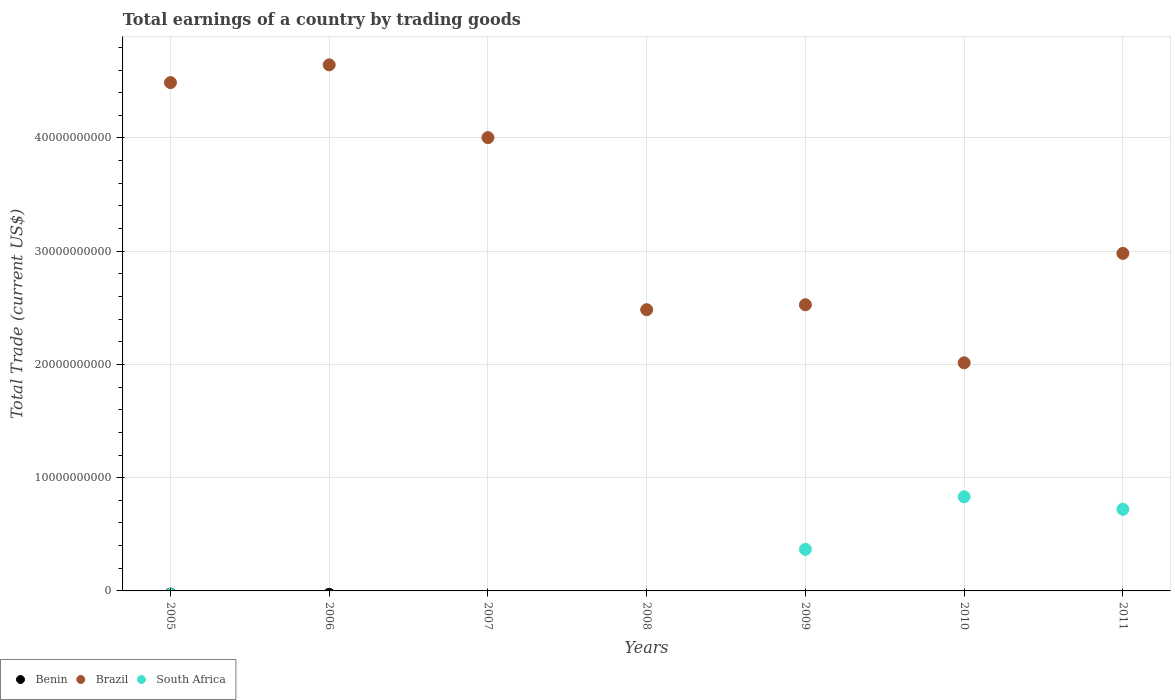Is the number of dotlines equal to the number of legend labels?
Provide a succinct answer. No. What is the total earnings in Benin in 2005?
Offer a very short reply. 0. Across all years, what is the maximum total earnings in Brazil?
Your response must be concise. 4.65e+1. Across all years, what is the minimum total earnings in South Africa?
Provide a succinct answer. 0. What is the total total earnings in Brazil in the graph?
Offer a very short reply. 2.31e+11. What is the difference between the total earnings in Brazil in 2007 and that in 2009?
Provide a short and direct response. 1.48e+1. What is the difference between the total earnings in South Africa in 2010 and the total earnings in Benin in 2008?
Your response must be concise. 8.31e+09. In the year 2009, what is the difference between the total earnings in South Africa and total earnings in Brazil?
Ensure brevity in your answer.  -2.16e+1. In how many years, is the total earnings in Brazil greater than 46000000000 US$?
Keep it short and to the point. 1. What is the ratio of the total earnings in Brazil in 2008 to that in 2011?
Your answer should be very brief. 0.83. Is the difference between the total earnings in South Africa in 2009 and 2011 greater than the difference between the total earnings in Brazil in 2009 and 2011?
Ensure brevity in your answer.  Yes. What is the difference between the highest and the second highest total earnings in Brazil?
Your answer should be very brief. 1.57e+09. What is the difference between the highest and the lowest total earnings in South Africa?
Provide a short and direct response. 8.31e+09. In how many years, is the total earnings in Benin greater than the average total earnings in Benin taken over all years?
Your answer should be compact. 0. Is the sum of the total earnings in Brazil in 2008 and 2010 greater than the maximum total earnings in Benin across all years?
Your answer should be compact. Yes. How many years are there in the graph?
Provide a succinct answer. 7. What is the difference between two consecutive major ticks on the Y-axis?
Make the answer very short. 1.00e+1. Does the graph contain grids?
Your answer should be compact. Yes. How are the legend labels stacked?
Your answer should be very brief. Horizontal. What is the title of the graph?
Provide a succinct answer. Total earnings of a country by trading goods. What is the label or title of the Y-axis?
Provide a succinct answer. Total Trade (current US$). What is the Total Trade (current US$) in Brazil in 2005?
Provide a short and direct response. 4.49e+1. What is the Total Trade (current US$) of Benin in 2006?
Make the answer very short. 0. What is the Total Trade (current US$) of Brazil in 2006?
Ensure brevity in your answer.  4.65e+1. What is the Total Trade (current US$) in Benin in 2007?
Keep it short and to the point. 0. What is the Total Trade (current US$) of Brazil in 2007?
Make the answer very short. 4.00e+1. What is the Total Trade (current US$) of South Africa in 2007?
Offer a terse response. 0. What is the Total Trade (current US$) of Brazil in 2008?
Offer a terse response. 2.48e+1. What is the Total Trade (current US$) in Benin in 2009?
Keep it short and to the point. 0. What is the Total Trade (current US$) in Brazil in 2009?
Keep it short and to the point. 2.53e+1. What is the Total Trade (current US$) of South Africa in 2009?
Your answer should be very brief. 3.67e+09. What is the Total Trade (current US$) in Benin in 2010?
Your answer should be compact. 0. What is the Total Trade (current US$) in Brazil in 2010?
Keep it short and to the point. 2.01e+1. What is the Total Trade (current US$) of South Africa in 2010?
Your answer should be compact. 8.31e+09. What is the Total Trade (current US$) in Benin in 2011?
Your answer should be compact. 0. What is the Total Trade (current US$) of Brazil in 2011?
Give a very brief answer. 2.98e+1. What is the Total Trade (current US$) of South Africa in 2011?
Ensure brevity in your answer.  7.21e+09. Across all years, what is the maximum Total Trade (current US$) in Brazil?
Provide a short and direct response. 4.65e+1. Across all years, what is the maximum Total Trade (current US$) of South Africa?
Offer a very short reply. 8.31e+09. Across all years, what is the minimum Total Trade (current US$) in Brazil?
Keep it short and to the point. 2.01e+1. Across all years, what is the minimum Total Trade (current US$) of South Africa?
Your answer should be compact. 0. What is the total Total Trade (current US$) of Brazil in the graph?
Provide a succinct answer. 2.31e+11. What is the total Total Trade (current US$) of South Africa in the graph?
Offer a very short reply. 1.92e+1. What is the difference between the Total Trade (current US$) in Brazil in 2005 and that in 2006?
Keep it short and to the point. -1.57e+09. What is the difference between the Total Trade (current US$) of Brazil in 2005 and that in 2007?
Make the answer very short. 4.86e+09. What is the difference between the Total Trade (current US$) in Brazil in 2005 and that in 2008?
Provide a succinct answer. 2.01e+1. What is the difference between the Total Trade (current US$) in Brazil in 2005 and that in 2009?
Your answer should be very brief. 1.96e+1. What is the difference between the Total Trade (current US$) in Brazil in 2005 and that in 2010?
Keep it short and to the point. 2.47e+1. What is the difference between the Total Trade (current US$) of Brazil in 2005 and that in 2011?
Make the answer very short. 1.51e+1. What is the difference between the Total Trade (current US$) of Brazil in 2006 and that in 2007?
Your response must be concise. 6.43e+09. What is the difference between the Total Trade (current US$) of Brazil in 2006 and that in 2008?
Provide a succinct answer. 2.16e+1. What is the difference between the Total Trade (current US$) of Brazil in 2006 and that in 2009?
Ensure brevity in your answer.  2.12e+1. What is the difference between the Total Trade (current US$) in Brazil in 2006 and that in 2010?
Give a very brief answer. 2.63e+1. What is the difference between the Total Trade (current US$) of Brazil in 2006 and that in 2011?
Ensure brevity in your answer.  1.67e+1. What is the difference between the Total Trade (current US$) of Brazil in 2007 and that in 2008?
Your answer should be very brief. 1.52e+1. What is the difference between the Total Trade (current US$) in Brazil in 2007 and that in 2009?
Ensure brevity in your answer.  1.48e+1. What is the difference between the Total Trade (current US$) in Brazil in 2007 and that in 2010?
Keep it short and to the point. 1.99e+1. What is the difference between the Total Trade (current US$) in Brazil in 2007 and that in 2011?
Your response must be concise. 1.02e+1. What is the difference between the Total Trade (current US$) in Brazil in 2008 and that in 2009?
Ensure brevity in your answer.  -4.36e+08. What is the difference between the Total Trade (current US$) in Brazil in 2008 and that in 2010?
Keep it short and to the point. 4.69e+09. What is the difference between the Total Trade (current US$) in Brazil in 2008 and that in 2011?
Make the answer very short. -4.97e+09. What is the difference between the Total Trade (current US$) in Brazil in 2009 and that in 2010?
Provide a short and direct response. 5.12e+09. What is the difference between the Total Trade (current US$) in South Africa in 2009 and that in 2010?
Give a very brief answer. -4.64e+09. What is the difference between the Total Trade (current US$) in Brazil in 2009 and that in 2011?
Provide a succinct answer. -4.54e+09. What is the difference between the Total Trade (current US$) of South Africa in 2009 and that in 2011?
Your answer should be compact. -3.53e+09. What is the difference between the Total Trade (current US$) of Brazil in 2010 and that in 2011?
Offer a terse response. -9.66e+09. What is the difference between the Total Trade (current US$) of South Africa in 2010 and that in 2011?
Ensure brevity in your answer.  1.10e+09. What is the difference between the Total Trade (current US$) in Brazil in 2005 and the Total Trade (current US$) in South Africa in 2009?
Provide a succinct answer. 4.12e+1. What is the difference between the Total Trade (current US$) in Brazil in 2005 and the Total Trade (current US$) in South Africa in 2010?
Keep it short and to the point. 3.66e+1. What is the difference between the Total Trade (current US$) of Brazil in 2005 and the Total Trade (current US$) of South Africa in 2011?
Ensure brevity in your answer.  3.77e+1. What is the difference between the Total Trade (current US$) in Brazil in 2006 and the Total Trade (current US$) in South Africa in 2009?
Make the answer very short. 4.28e+1. What is the difference between the Total Trade (current US$) in Brazil in 2006 and the Total Trade (current US$) in South Africa in 2010?
Offer a very short reply. 3.81e+1. What is the difference between the Total Trade (current US$) of Brazil in 2006 and the Total Trade (current US$) of South Africa in 2011?
Keep it short and to the point. 3.93e+1. What is the difference between the Total Trade (current US$) in Brazil in 2007 and the Total Trade (current US$) in South Africa in 2009?
Your answer should be compact. 3.64e+1. What is the difference between the Total Trade (current US$) in Brazil in 2007 and the Total Trade (current US$) in South Africa in 2010?
Give a very brief answer. 3.17e+1. What is the difference between the Total Trade (current US$) in Brazil in 2007 and the Total Trade (current US$) in South Africa in 2011?
Provide a succinct answer. 3.28e+1. What is the difference between the Total Trade (current US$) of Brazil in 2008 and the Total Trade (current US$) of South Africa in 2009?
Offer a very short reply. 2.12e+1. What is the difference between the Total Trade (current US$) of Brazil in 2008 and the Total Trade (current US$) of South Africa in 2010?
Make the answer very short. 1.65e+1. What is the difference between the Total Trade (current US$) of Brazil in 2008 and the Total Trade (current US$) of South Africa in 2011?
Provide a succinct answer. 1.76e+1. What is the difference between the Total Trade (current US$) of Brazil in 2009 and the Total Trade (current US$) of South Africa in 2010?
Ensure brevity in your answer.  1.70e+1. What is the difference between the Total Trade (current US$) in Brazil in 2009 and the Total Trade (current US$) in South Africa in 2011?
Your answer should be compact. 1.81e+1. What is the difference between the Total Trade (current US$) of Brazil in 2010 and the Total Trade (current US$) of South Africa in 2011?
Offer a terse response. 1.29e+1. What is the average Total Trade (current US$) in Benin per year?
Ensure brevity in your answer.  0. What is the average Total Trade (current US$) of Brazil per year?
Give a very brief answer. 3.31e+1. What is the average Total Trade (current US$) in South Africa per year?
Your answer should be compact. 2.74e+09. In the year 2009, what is the difference between the Total Trade (current US$) of Brazil and Total Trade (current US$) of South Africa?
Your answer should be very brief. 2.16e+1. In the year 2010, what is the difference between the Total Trade (current US$) in Brazil and Total Trade (current US$) in South Africa?
Give a very brief answer. 1.18e+1. In the year 2011, what is the difference between the Total Trade (current US$) of Brazil and Total Trade (current US$) of South Africa?
Your answer should be compact. 2.26e+1. What is the ratio of the Total Trade (current US$) in Brazil in 2005 to that in 2006?
Give a very brief answer. 0.97. What is the ratio of the Total Trade (current US$) of Brazil in 2005 to that in 2007?
Offer a terse response. 1.12. What is the ratio of the Total Trade (current US$) in Brazil in 2005 to that in 2008?
Your answer should be very brief. 1.81. What is the ratio of the Total Trade (current US$) of Brazil in 2005 to that in 2009?
Your response must be concise. 1.78. What is the ratio of the Total Trade (current US$) of Brazil in 2005 to that in 2010?
Keep it short and to the point. 2.23. What is the ratio of the Total Trade (current US$) in Brazil in 2005 to that in 2011?
Your answer should be very brief. 1.51. What is the ratio of the Total Trade (current US$) in Brazil in 2006 to that in 2007?
Keep it short and to the point. 1.16. What is the ratio of the Total Trade (current US$) in Brazil in 2006 to that in 2008?
Offer a very short reply. 1.87. What is the ratio of the Total Trade (current US$) of Brazil in 2006 to that in 2009?
Give a very brief answer. 1.84. What is the ratio of the Total Trade (current US$) in Brazil in 2006 to that in 2010?
Offer a very short reply. 2.31. What is the ratio of the Total Trade (current US$) of Brazil in 2006 to that in 2011?
Give a very brief answer. 1.56. What is the ratio of the Total Trade (current US$) in Brazil in 2007 to that in 2008?
Keep it short and to the point. 1.61. What is the ratio of the Total Trade (current US$) of Brazil in 2007 to that in 2009?
Provide a short and direct response. 1.58. What is the ratio of the Total Trade (current US$) in Brazil in 2007 to that in 2010?
Make the answer very short. 1.99. What is the ratio of the Total Trade (current US$) of Brazil in 2007 to that in 2011?
Your answer should be very brief. 1.34. What is the ratio of the Total Trade (current US$) in Brazil in 2008 to that in 2009?
Provide a succinct answer. 0.98. What is the ratio of the Total Trade (current US$) in Brazil in 2008 to that in 2010?
Your response must be concise. 1.23. What is the ratio of the Total Trade (current US$) of Brazil in 2008 to that in 2011?
Keep it short and to the point. 0.83. What is the ratio of the Total Trade (current US$) of Brazil in 2009 to that in 2010?
Provide a short and direct response. 1.25. What is the ratio of the Total Trade (current US$) of South Africa in 2009 to that in 2010?
Your response must be concise. 0.44. What is the ratio of the Total Trade (current US$) of Brazil in 2009 to that in 2011?
Your response must be concise. 0.85. What is the ratio of the Total Trade (current US$) of South Africa in 2009 to that in 2011?
Your answer should be very brief. 0.51. What is the ratio of the Total Trade (current US$) of Brazil in 2010 to that in 2011?
Your answer should be compact. 0.68. What is the ratio of the Total Trade (current US$) of South Africa in 2010 to that in 2011?
Provide a succinct answer. 1.15. What is the difference between the highest and the second highest Total Trade (current US$) in Brazil?
Offer a very short reply. 1.57e+09. What is the difference between the highest and the second highest Total Trade (current US$) of South Africa?
Provide a succinct answer. 1.10e+09. What is the difference between the highest and the lowest Total Trade (current US$) in Brazil?
Keep it short and to the point. 2.63e+1. What is the difference between the highest and the lowest Total Trade (current US$) of South Africa?
Keep it short and to the point. 8.31e+09. 